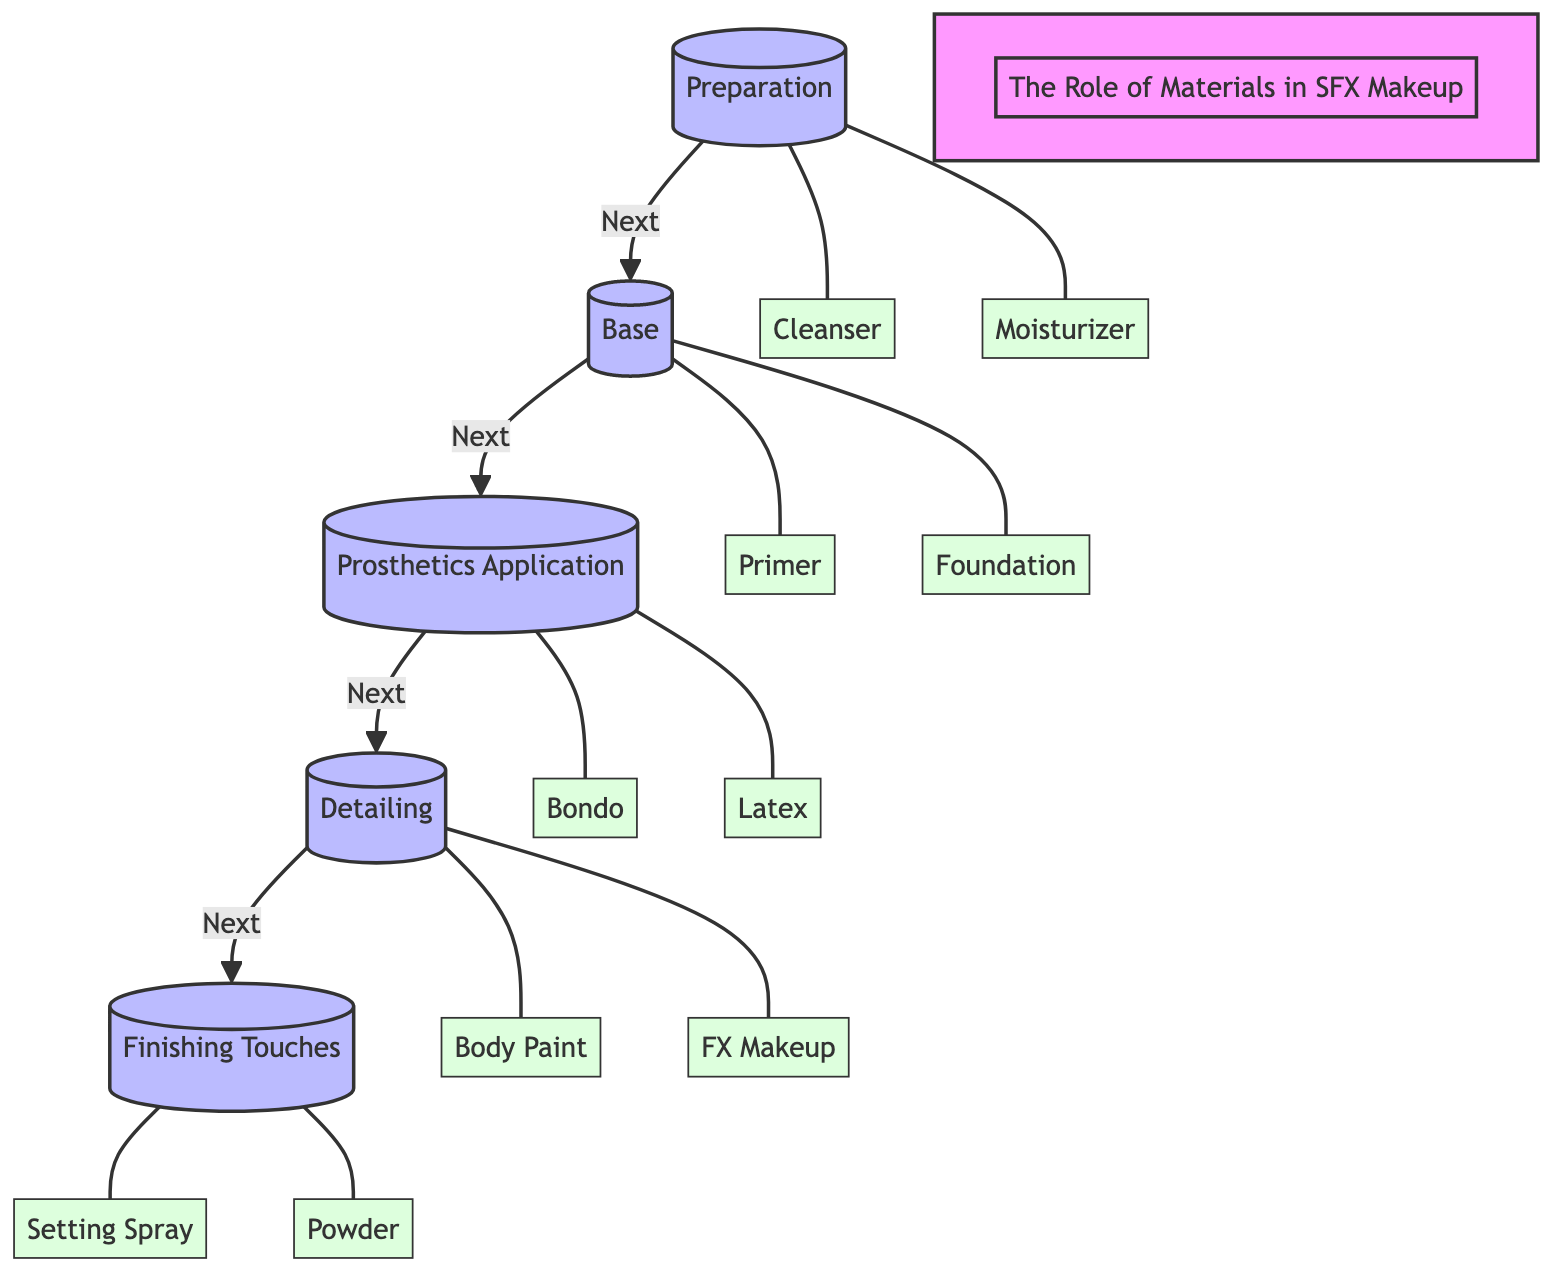What are the five stages of SFX makeup outlined in the diagram? The diagram lists five stages: Preparation, Base, Prosthetics Application, Detailing, and Finishing Touches. Each stage is sequentially linked to the next.
Answer: Preparation, Base, Prosthetics Application, Detailing, Finishing Touches Which product is used in the Preparation stage? In the Preparation stage, two products are listed: Cleanser and Moisturizer. They are connected directly to the Preparation stage.
Answer: Cleanser, Moisturizer How many products are associated with the Finishing Touches stage? The Finishing Touches stage has two associated products: Setting Spray and Powder. These products are directly linked to the respective stage.
Answer: 2 Which product is applied after Foundation in the diagram? The progression from the Base stage shows that after Foundation, the next step is Prosthetics Application. Bondo and Latex are the products applied after the Base stage.
Answer: Bondo, Latex What links the Detail stage to the Finishing Touches stage? The progression in the diagram shows that after detailing, the flow advances directly to the Finishing Touches stage, indicating a flow of processes in SFX makeup.
Answer: Next Which product is primarily used for detailing? According to the diagram, Body Paint and FX Makeup are the products used in the Detailing stage, specifically aimed at detailing the makeup effects.
Answer: Body Paint, FX Makeup How does the transition occur from the Prosthetics Application stage to the Detailing stage? The flowchart indicates a direct connection between the Prosthetics Application stage and the Detailing stage, signifying that after applying prosthetics, the makeup transitions into detailing.
Answer: Next What is the primary focus of the diagram? The primary purpose of the diagram is to illustrate the role of materials in SFX makeup by breaking down the tools and products used at each stage of character creation.
Answer: The Role of Materials in SFX Makeup 